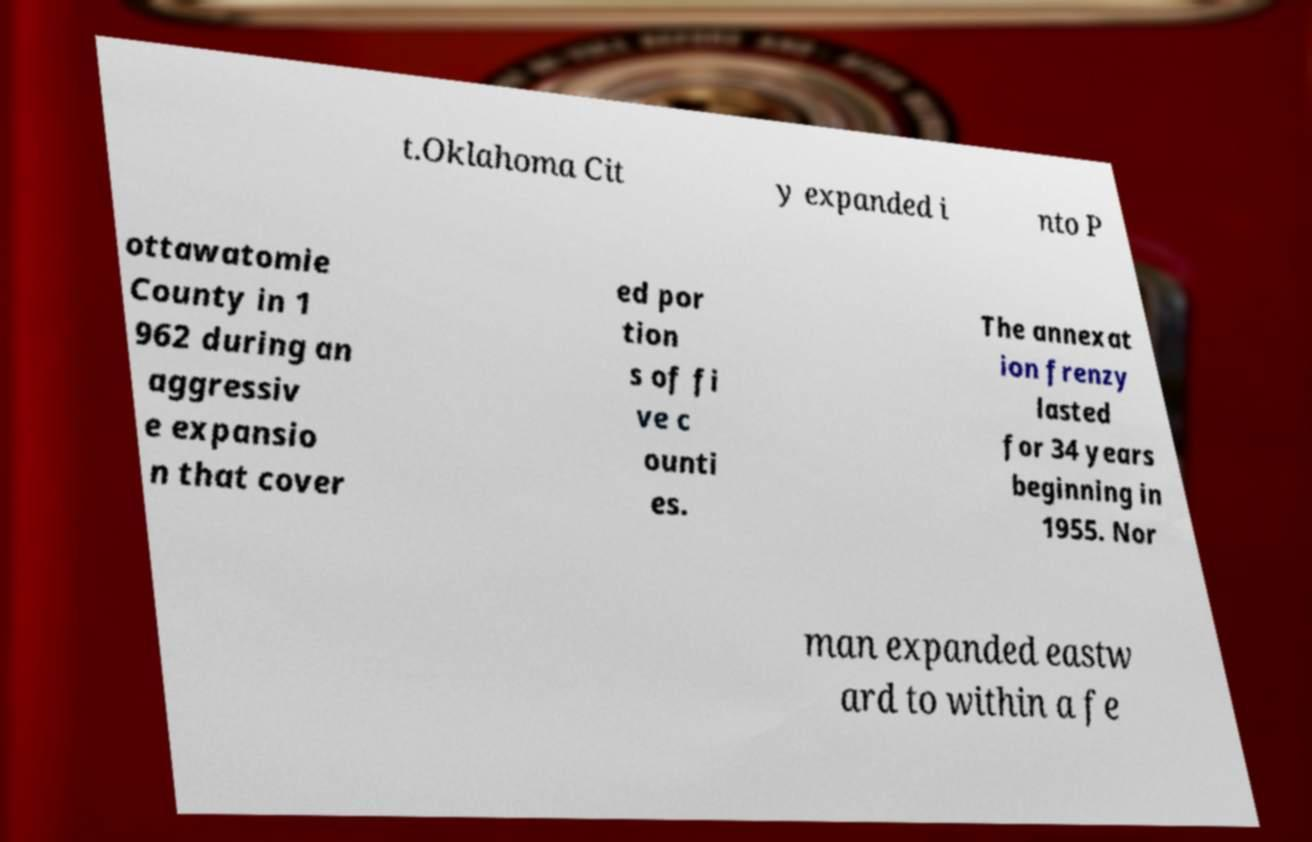Please identify and transcribe the text found in this image. t.Oklahoma Cit y expanded i nto P ottawatomie County in 1 962 during an aggressiv e expansio n that cover ed por tion s of fi ve c ounti es. The annexat ion frenzy lasted for 34 years beginning in 1955. Nor man expanded eastw ard to within a fe 